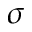Convert formula to latex. <formula><loc_0><loc_0><loc_500><loc_500>\sigma</formula> 